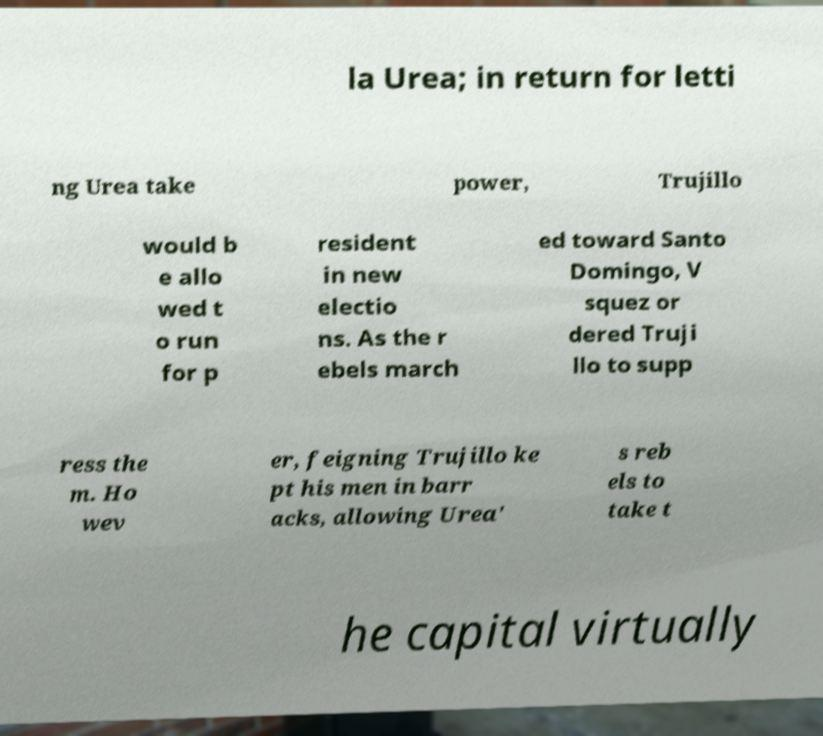Can you accurately transcribe the text from the provided image for me? la Urea; in return for letti ng Urea take power, Trujillo would b e allo wed t o run for p resident in new electio ns. As the r ebels march ed toward Santo Domingo, V squez or dered Truji llo to supp ress the m. Ho wev er, feigning Trujillo ke pt his men in barr acks, allowing Urea' s reb els to take t he capital virtually 